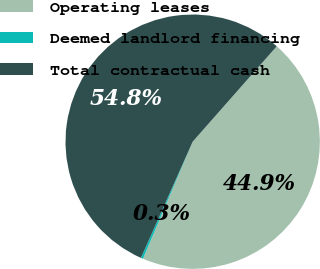<chart> <loc_0><loc_0><loc_500><loc_500><pie_chart><fcel>Operating leases<fcel>Deemed landlord financing<fcel>Total contractual cash<nl><fcel>44.9%<fcel>0.27%<fcel>54.83%<nl></chart> 